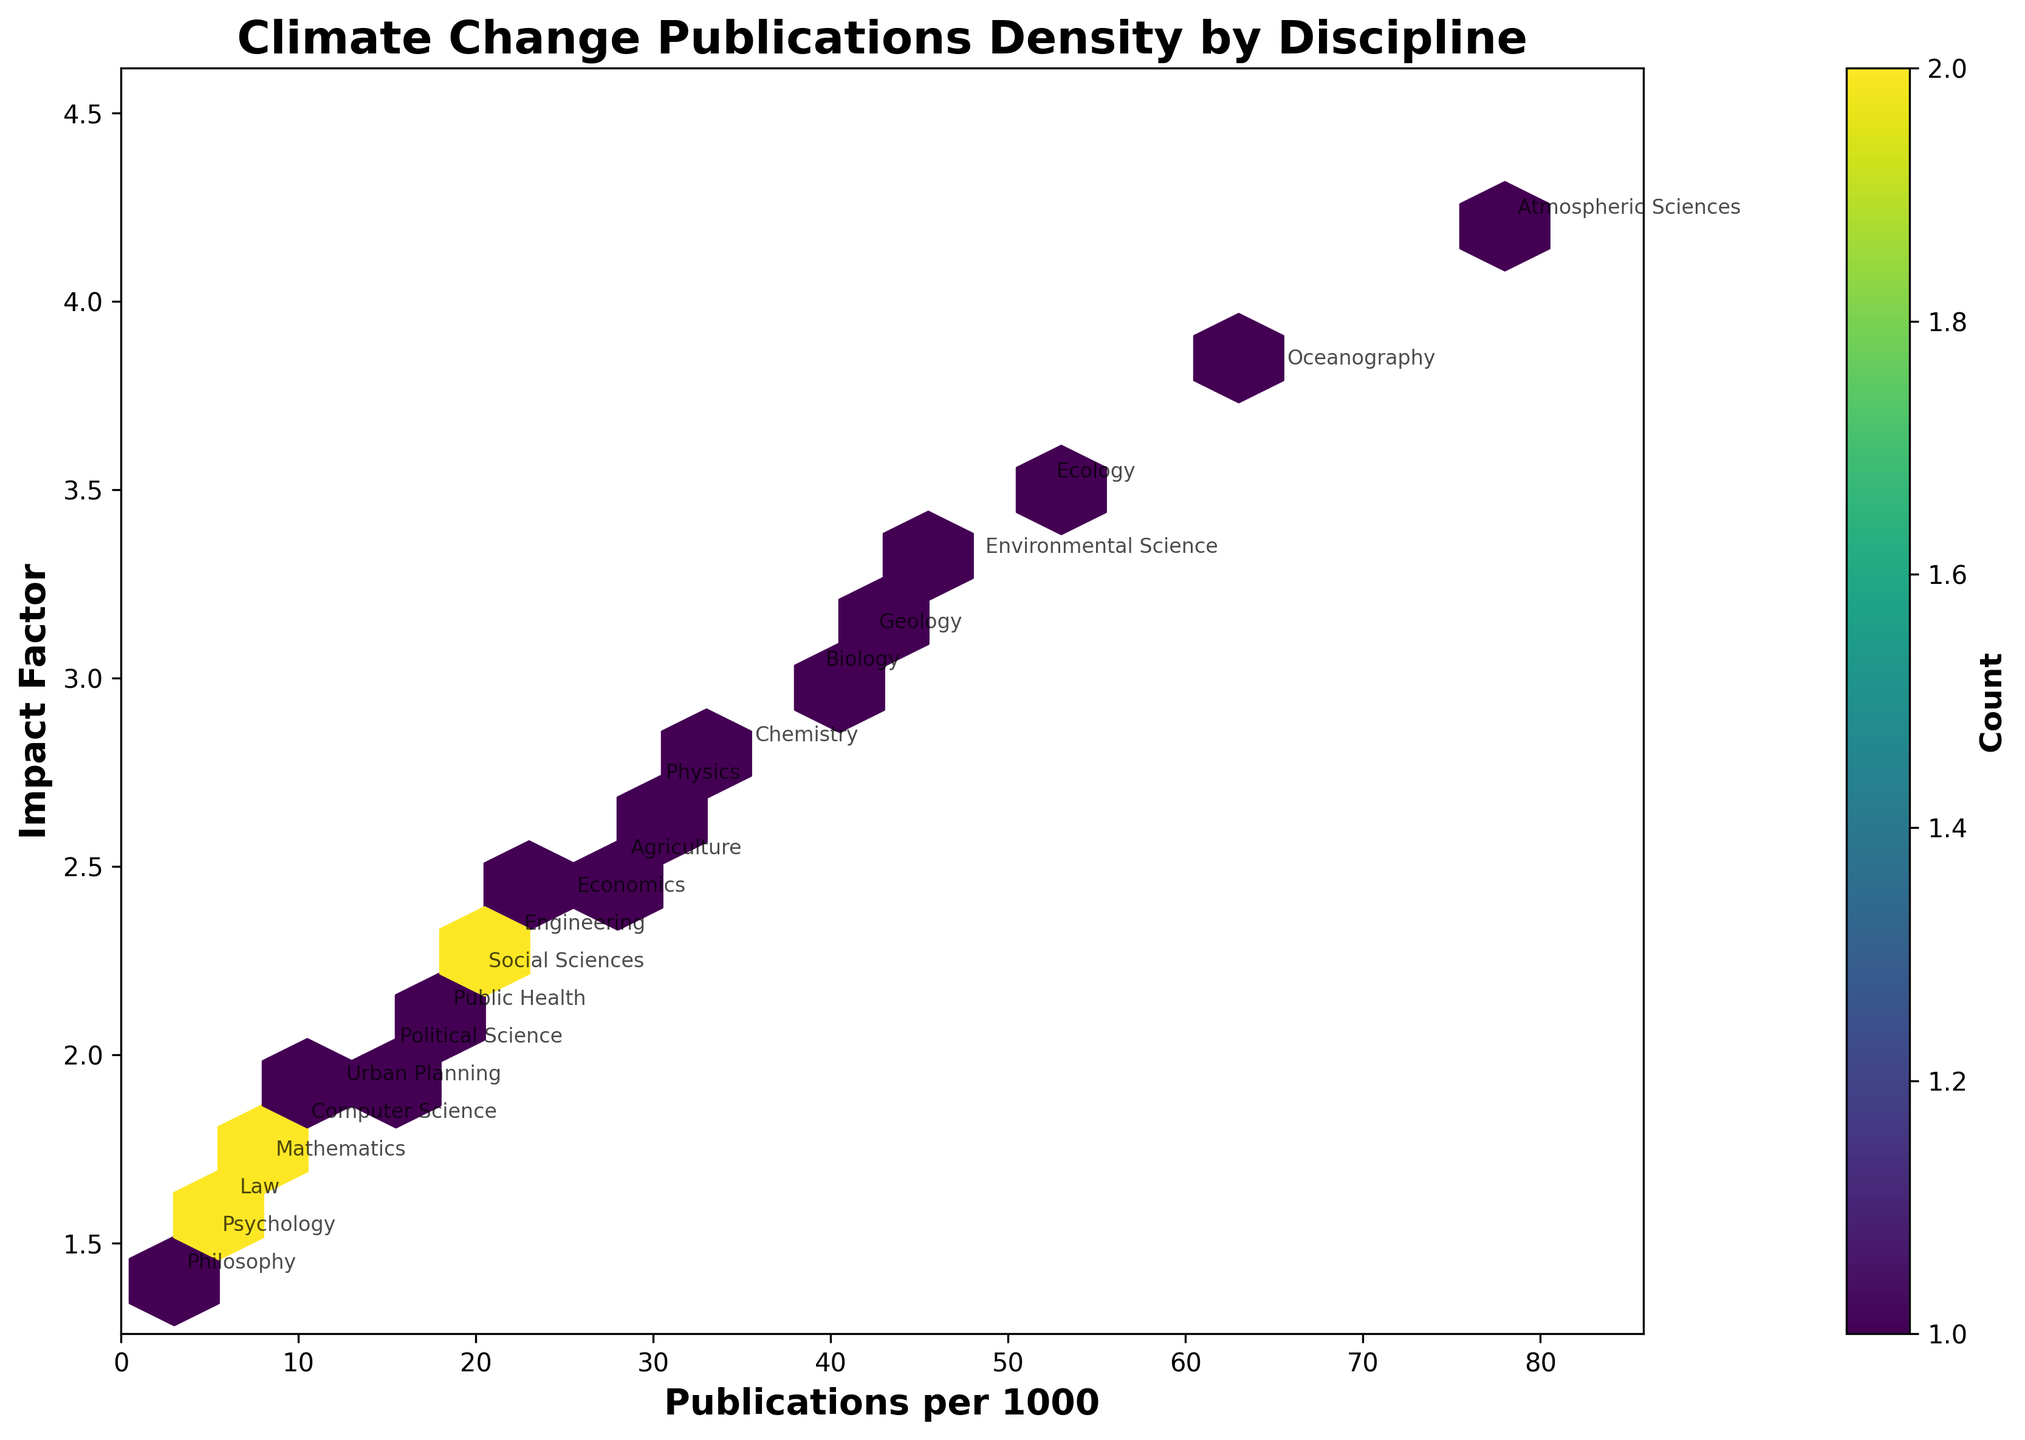What is the title of the figure? The title is clearly indicated at the top of the figure, which summarizes the main subject of the plot.
Answer: Climate Change Publications Density by Discipline How many disciplines have their data points annotated in the plot? Count the number of annotations visible on the plot, which labels each discipline.
Answer: 20 What is the range of Impact Factors on the y-axis? Observe the minimum and maximum Impact Factor values marked on the y-axis.
Answer: 1.4 to 4.2 Which discipline has the highest number of publications per 1000? Look for the highest value on the x-axis and find which discipline's annotation corresponds to it.
Answer: Atmospheric Sciences Which disciplines fall within the hexbin with the highest density of publications per 1000? Identify the hexbin with the darkest color (indicating the highest density) and check annotations within it. Various disciplines can be grouped in that area.
Answer: Atmospheric Sciences, Oceanography, Ecology What is the average Impact Factor of the disciplines with more than 30 publications per 1000? Determine which disciplines have more than 30 publications per 1000, sum their Impact Factors, and divide by the number of disciplines.
Answer: (4.2 + 3.8 + 3.5 + 3.3 + 3.1 + 3.0 + 2.8 + 2.7) / 8 = 3.3 Which discipline has the lowest Impact Factor and what is its number of publications per 1000? Identify the discipline with the lowest y-axis value and note its corresponding x-axis value.
Answer: Philosophy, 3 How do the number of publications per 1000 in Biology compare to those in Geology? Find the x-axis positions for Biology and Geology and compare their values.
Answer: Biology has 39 publications per 1000, Geology has 42 Which discipline lies close to the middle in terms of both publications per 1000 and Impact Factor? Locate the data point approximately in the middle of both axes and identify the annotation around it.
Answer: Chemistry How does the distribution of Impact Factors appear for disciplines with fewer than 20 publications per 1000? Look at the spread and density of the y values for data points where x values are less than 20.
Answer: The Impact Factors range from 1.4 to 2.2 